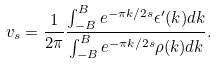Convert formula to latex. <formula><loc_0><loc_0><loc_500><loc_500>v _ { s } = \frac { 1 } { 2 \pi } \frac { \int _ { - B } ^ { B } e ^ { - \pi k / 2 s } \epsilon ^ { \prime } ( k ) d k } { \int _ { - B } ^ { B } e ^ { - \pi k / 2 s } \rho ( k ) d k } .</formula> 